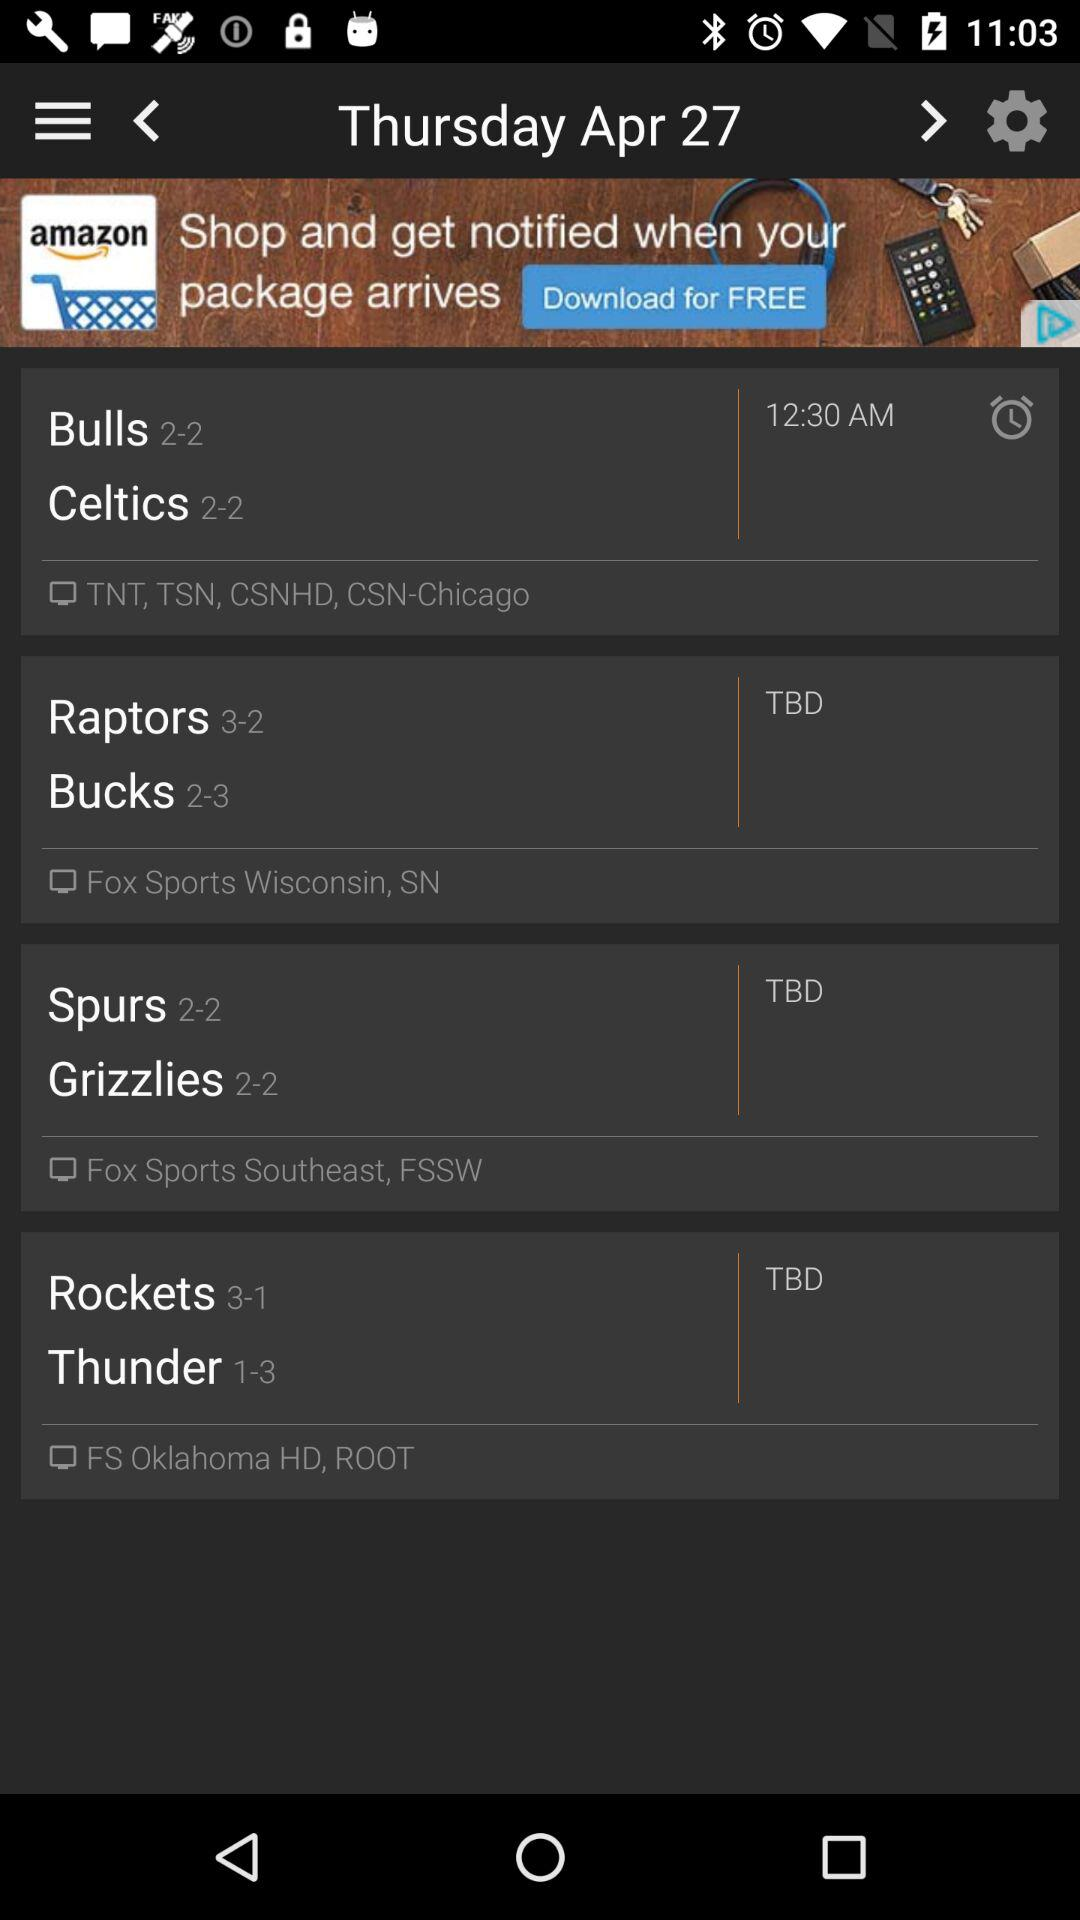What is the given time? The given time is 12:30 AM. 